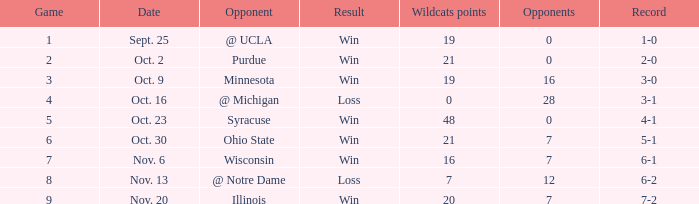What is the minimum points scored by the wildcats when the record was 5-1? 21.0. 